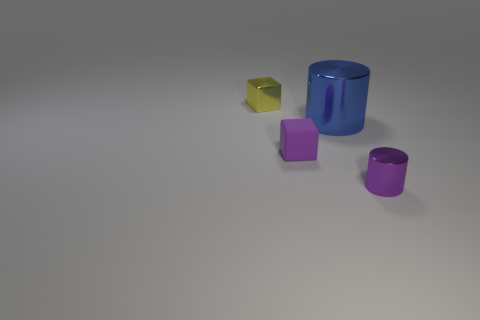Subtract 1 blocks. How many blocks are left? 1 Add 2 green rubber cylinders. How many objects exist? 6 Subtract all purple cubes. How many cubes are left? 1 Subtract all purple cylinders. How many brown blocks are left? 0 Subtract all blue metal cylinders. Subtract all purple rubber cubes. How many objects are left? 2 Add 3 tiny yellow cubes. How many tiny yellow cubes are left? 4 Add 4 large yellow metal blocks. How many large yellow metal blocks exist? 4 Subtract 1 yellow cubes. How many objects are left? 3 Subtract all purple cubes. Subtract all blue spheres. How many cubes are left? 1 